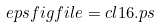Convert formula to latex. <formula><loc_0><loc_0><loc_500><loc_500>\ e p s f i g { f i l e = c l 1 6 . p s }</formula> 